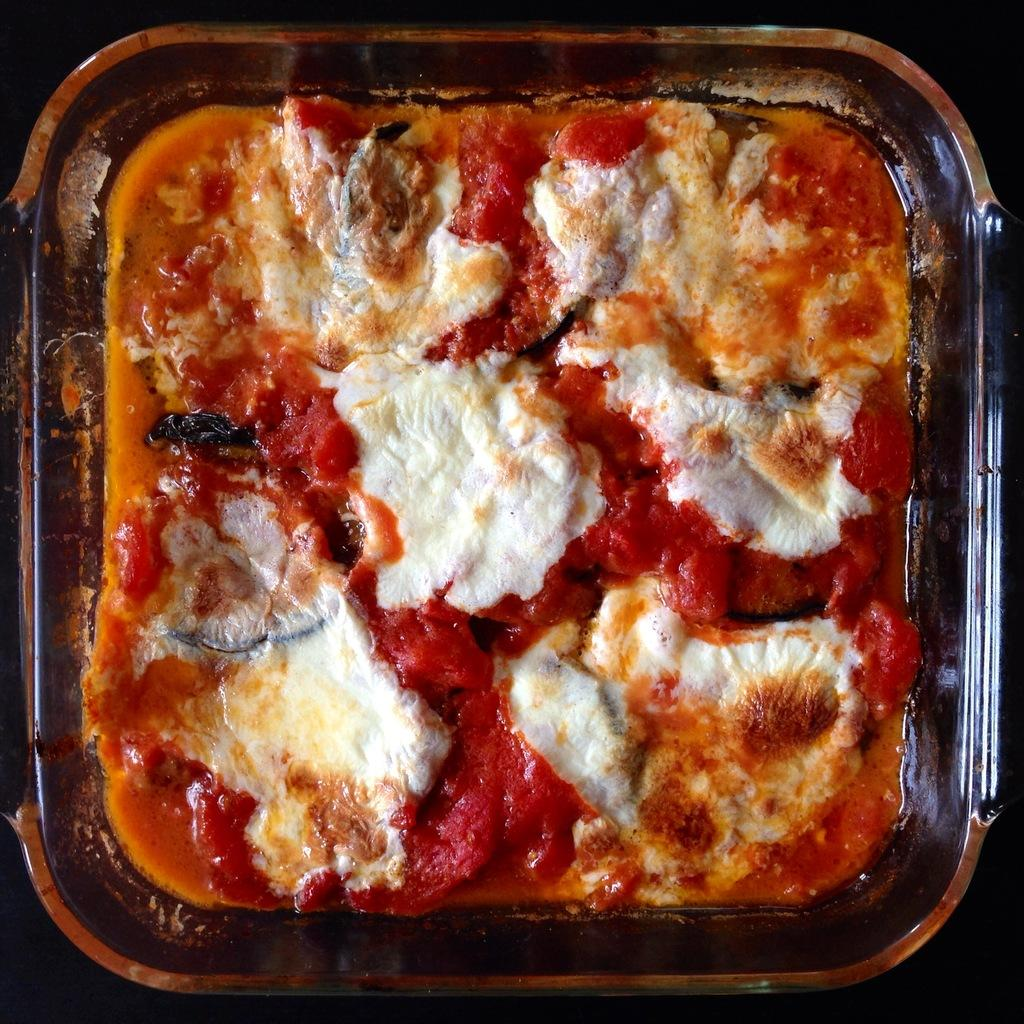What object is present in the image that is used for holding food? There is a plastic plate in the image that is used for holding food. What type of food is on the plastic plate? The food on the plastic plate has a white and red color. What type of shade is covering the food on the plastic plate? There is no shade covering the food on the plastic plate in the image. How is the hose being used in the image? There is no hose present in the image. 